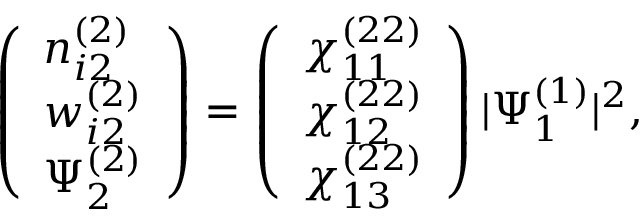<formula> <loc_0><loc_0><loc_500><loc_500>\begin{array} { r } { \left ( \begin{array} { l } { n _ { i 2 } ^ { ( 2 ) } } \\ { w _ { i 2 } ^ { ( 2 ) } } \\ { \Psi _ { 2 } ^ { ( 2 ) } } \end{array} \right ) = \left ( \begin{array} { l } { \chi _ { 1 1 } ^ { ( 2 2 ) } } \\ { \chi _ { 1 2 } ^ { ( 2 2 ) } } \\ { \chi _ { 1 3 } ^ { ( 2 2 ) } } \end{array} \right ) | \Psi _ { 1 } ^ { ( 1 ) } | ^ { 2 } , } \end{array}</formula> 